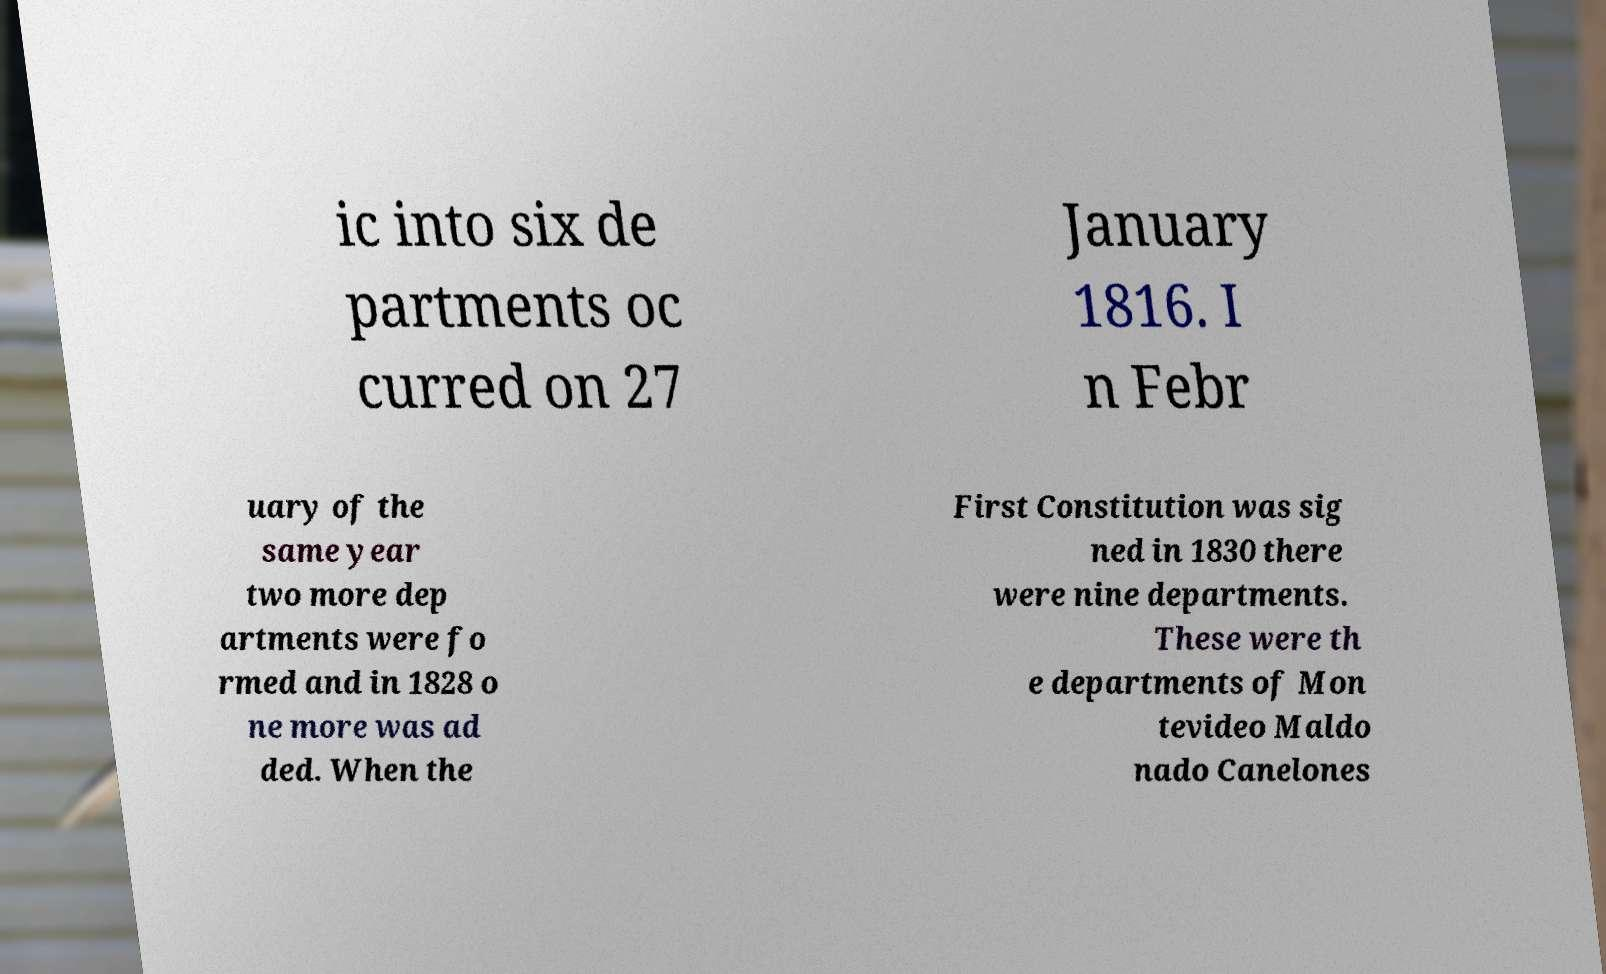I need the written content from this picture converted into text. Can you do that? ic into six de partments oc curred on 27 January 1816. I n Febr uary of the same year two more dep artments were fo rmed and in 1828 o ne more was ad ded. When the First Constitution was sig ned in 1830 there were nine departments. These were th e departments of Mon tevideo Maldo nado Canelones 